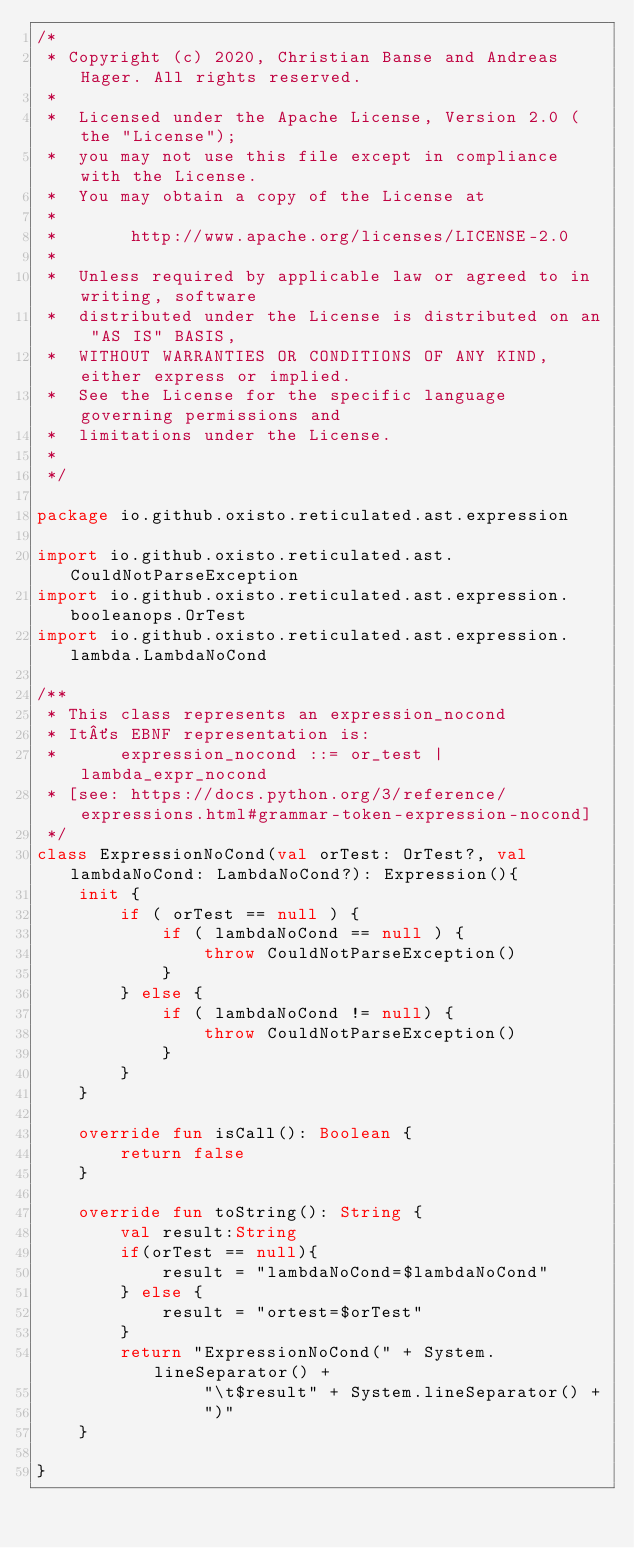Convert code to text. <code><loc_0><loc_0><loc_500><loc_500><_Kotlin_>/*
 * Copyright (c) 2020, Christian Banse and Andreas Hager. All rights reserved.
 *
 *  Licensed under the Apache License, Version 2.0 (the "License");
 *  you may not use this file except in compliance with the License.
 *  You may obtain a copy of the License at
 *
 *       http://www.apache.org/licenses/LICENSE-2.0
 *
 *  Unless required by applicable law or agreed to in writing, software
 *  distributed under the License is distributed on an "AS IS" BASIS,
 *  WITHOUT WARRANTIES OR CONDITIONS OF ANY KIND, either express or implied.
 *  See the License for the specific language governing permissions and
 *  limitations under the License.
 *
 */

package io.github.oxisto.reticulated.ast.expression

import io.github.oxisto.reticulated.ast.CouldNotParseException
import io.github.oxisto.reticulated.ast.expression.booleanops.OrTest
import io.github.oxisto.reticulated.ast.expression.lambda.LambdaNoCond

/**
 * This class represents an expression_nocond
 * It´s EBNF representation is:
 *      expression_nocond ::= or_test | lambda_expr_nocond
 * [see: https://docs.python.org/3/reference/expressions.html#grammar-token-expression-nocond]
 */
class ExpressionNoCond(val orTest: OrTest?, val lambdaNoCond: LambdaNoCond?): Expression(){
    init {
        if ( orTest == null ) {
            if ( lambdaNoCond == null ) {
                throw CouldNotParseException()
            }
        } else {
            if ( lambdaNoCond != null) {
                throw CouldNotParseException()
            }
        }
    }

    override fun isCall(): Boolean {
        return false
    }

    override fun toString(): String {
        val result:String
        if(orTest == null){
            result = "lambdaNoCond=$lambdaNoCond"
        } else {
            result = "ortest=$orTest"
        }
        return "ExpressionNoCond(" + System.lineSeparator() +
                "\t$result" + System.lineSeparator() +
                ")"
    }

}</code> 